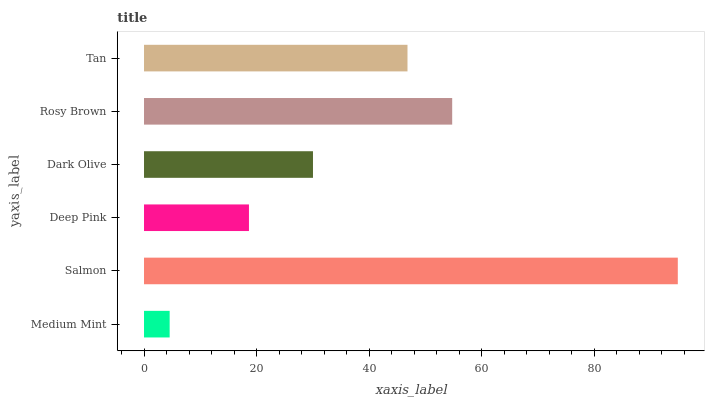Is Medium Mint the minimum?
Answer yes or no. Yes. Is Salmon the maximum?
Answer yes or no. Yes. Is Deep Pink the minimum?
Answer yes or no. No. Is Deep Pink the maximum?
Answer yes or no. No. Is Salmon greater than Deep Pink?
Answer yes or no. Yes. Is Deep Pink less than Salmon?
Answer yes or no. Yes. Is Deep Pink greater than Salmon?
Answer yes or no. No. Is Salmon less than Deep Pink?
Answer yes or no. No. Is Tan the high median?
Answer yes or no. Yes. Is Dark Olive the low median?
Answer yes or no. Yes. Is Salmon the high median?
Answer yes or no. No. Is Salmon the low median?
Answer yes or no. No. 